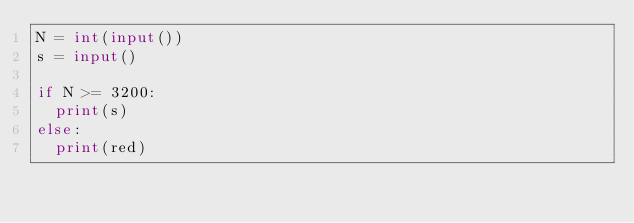Convert code to text. <code><loc_0><loc_0><loc_500><loc_500><_Python_>N = int(input())
s = input()

if N >= 3200:
  print(s)
else:
  print(red)</code> 